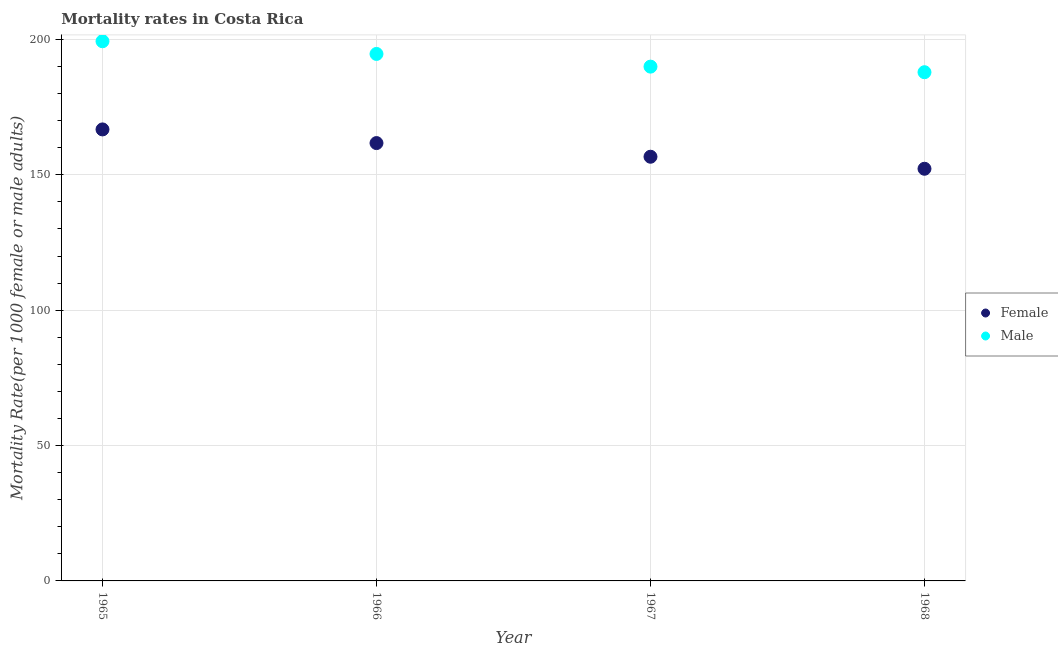How many different coloured dotlines are there?
Provide a short and direct response. 2. What is the male mortality rate in 1965?
Your answer should be compact. 199.33. Across all years, what is the maximum female mortality rate?
Provide a succinct answer. 166.76. Across all years, what is the minimum male mortality rate?
Keep it short and to the point. 187.89. In which year was the female mortality rate maximum?
Offer a very short reply. 1965. In which year was the male mortality rate minimum?
Provide a short and direct response. 1968. What is the total female mortality rate in the graph?
Ensure brevity in your answer.  637.38. What is the difference between the female mortality rate in 1965 and that in 1968?
Offer a terse response. 14.53. What is the difference between the male mortality rate in 1968 and the female mortality rate in 1967?
Your answer should be compact. 31.22. What is the average female mortality rate per year?
Ensure brevity in your answer.  159.34. In the year 1965, what is the difference between the male mortality rate and female mortality rate?
Ensure brevity in your answer.  32.56. What is the ratio of the female mortality rate in 1966 to that in 1967?
Your response must be concise. 1.03. Is the difference between the male mortality rate in 1965 and 1966 greater than the difference between the female mortality rate in 1965 and 1966?
Ensure brevity in your answer.  No. What is the difference between the highest and the second highest male mortality rate?
Offer a very short reply. 4.69. What is the difference between the highest and the lowest male mortality rate?
Offer a terse response. 11.43. Is the sum of the female mortality rate in 1965 and 1967 greater than the maximum male mortality rate across all years?
Your response must be concise. Yes. Is the male mortality rate strictly greater than the female mortality rate over the years?
Offer a very short reply. Yes. Is the male mortality rate strictly less than the female mortality rate over the years?
Provide a succinct answer. No. How many dotlines are there?
Offer a very short reply. 2. How many years are there in the graph?
Offer a very short reply. 4. What is the difference between two consecutive major ticks on the Y-axis?
Offer a terse response. 50. Are the values on the major ticks of Y-axis written in scientific E-notation?
Give a very brief answer. No. Does the graph contain any zero values?
Make the answer very short. No. What is the title of the graph?
Offer a terse response. Mortality rates in Costa Rica. What is the label or title of the Y-axis?
Offer a very short reply. Mortality Rate(per 1000 female or male adults). What is the Mortality Rate(per 1000 female or male adults) of Female in 1965?
Make the answer very short. 166.76. What is the Mortality Rate(per 1000 female or male adults) of Male in 1965?
Your response must be concise. 199.33. What is the Mortality Rate(per 1000 female or male adults) of Female in 1966?
Give a very brief answer. 161.72. What is the Mortality Rate(per 1000 female or male adults) in Male in 1966?
Offer a very short reply. 194.64. What is the Mortality Rate(per 1000 female or male adults) in Female in 1967?
Keep it short and to the point. 156.67. What is the Mortality Rate(per 1000 female or male adults) of Male in 1967?
Your answer should be compact. 189.95. What is the Mortality Rate(per 1000 female or male adults) in Female in 1968?
Provide a short and direct response. 152.23. What is the Mortality Rate(per 1000 female or male adults) of Male in 1968?
Give a very brief answer. 187.89. Across all years, what is the maximum Mortality Rate(per 1000 female or male adults) of Female?
Your response must be concise. 166.76. Across all years, what is the maximum Mortality Rate(per 1000 female or male adults) in Male?
Offer a very short reply. 199.33. Across all years, what is the minimum Mortality Rate(per 1000 female or male adults) in Female?
Your answer should be very brief. 152.23. Across all years, what is the minimum Mortality Rate(per 1000 female or male adults) of Male?
Your answer should be compact. 187.89. What is the total Mortality Rate(per 1000 female or male adults) in Female in the graph?
Your answer should be compact. 637.38. What is the total Mortality Rate(per 1000 female or male adults) of Male in the graph?
Keep it short and to the point. 771.81. What is the difference between the Mortality Rate(per 1000 female or male adults) of Female in 1965 and that in 1966?
Your response must be concise. 5.04. What is the difference between the Mortality Rate(per 1000 female or male adults) in Male in 1965 and that in 1966?
Provide a short and direct response. 4.69. What is the difference between the Mortality Rate(per 1000 female or male adults) of Female in 1965 and that in 1967?
Give a very brief answer. 10.09. What is the difference between the Mortality Rate(per 1000 female or male adults) of Male in 1965 and that in 1967?
Make the answer very short. 9.37. What is the difference between the Mortality Rate(per 1000 female or male adults) in Female in 1965 and that in 1968?
Ensure brevity in your answer.  14.53. What is the difference between the Mortality Rate(per 1000 female or male adults) in Male in 1965 and that in 1968?
Make the answer very short. 11.43. What is the difference between the Mortality Rate(per 1000 female or male adults) of Female in 1966 and that in 1967?
Ensure brevity in your answer.  5.04. What is the difference between the Mortality Rate(per 1000 female or male adults) of Male in 1966 and that in 1967?
Your answer should be very brief. 4.69. What is the difference between the Mortality Rate(per 1000 female or male adults) of Female in 1966 and that in 1968?
Provide a succinct answer. 9.49. What is the difference between the Mortality Rate(per 1000 female or male adults) in Male in 1966 and that in 1968?
Your answer should be compact. 6.75. What is the difference between the Mortality Rate(per 1000 female or male adults) in Female in 1967 and that in 1968?
Ensure brevity in your answer.  4.44. What is the difference between the Mortality Rate(per 1000 female or male adults) of Male in 1967 and that in 1968?
Your answer should be compact. 2.06. What is the difference between the Mortality Rate(per 1000 female or male adults) in Female in 1965 and the Mortality Rate(per 1000 female or male adults) in Male in 1966?
Give a very brief answer. -27.88. What is the difference between the Mortality Rate(per 1000 female or male adults) in Female in 1965 and the Mortality Rate(per 1000 female or male adults) in Male in 1967?
Your answer should be compact. -23.19. What is the difference between the Mortality Rate(per 1000 female or male adults) in Female in 1965 and the Mortality Rate(per 1000 female or male adults) in Male in 1968?
Provide a succinct answer. -21.13. What is the difference between the Mortality Rate(per 1000 female or male adults) of Female in 1966 and the Mortality Rate(per 1000 female or male adults) of Male in 1967?
Offer a very short reply. -28.24. What is the difference between the Mortality Rate(per 1000 female or male adults) in Female in 1966 and the Mortality Rate(per 1000 female or male adults) in Male in 1968?
Your response must be concise. -26.18. What is the difference between the Mortality Rate(per 1000 female or male adults) of Female in 1967 and the Mortality Rate(per 1000 female or male adults) of Male in 1968?
Ensure brevity in your answer.  -31.22. What is the average Mortality Rate(per 1000 female or male adults) in Female per year?
Keep it short and to the point. 159.34. What is the average Mortality Rate(per 1000 female or male adults) in Male per year?
Your response must be concise. 192.95. In the year 1965, what is the difference between the Mortality Rate(per 1000 female or male adults) of Female and Mortality Rate(per 1000 female or male adults) of Male?
Make the answer very short. -32.56. In the year 1966, what is the difference between the Mortality Rate(per 1000 female or male adults) in Female and Mortality Rate(per 1000 female or male adults) in Male?
Your answer should be compact. -32.92. In the year 1967, what is the difference between the Mortality Rate(per 1000 female or male adults) of Female and Mortality Rate(per 1000 female or male adults) of Male?
Your response must be concise. -33.28. In the year 1968, what is the difference between the Mortality Rate(per 1000 female or male adults) in Female and Mortality Rate(per 1000 female or male adults) in Male?
Give a very brief answer. -35.66. What is the ratio of the Mortality Rate(per 1000 female or male adults) in Female in 1965 to that in 1966?
Offer a terse response. 1.03. What is the ratio of the Mortality Rate(per 1000 female or male adults) of Male in 1965 to that in 1966?
Keep it short and to the point. 1.02. What is the ratio of the Mortality Rate(per 1000 female or male adults) in Female in 1965 to that in 1967?
Provide a succinct answer. 1.06. What is the ratio of the Mortality Rate(per 1000 female or male adults) in Male in 1965 to that in 1967?
Your answer should be very brief. 1.05. What is the ratio of the Mortality Rate(per 1000 female or male adults) of Female in 1965 to that in 1968?
Make the answer very short. 1.1. What is the ratio of the Mortality Rate(per 1000 female or male adults) in Male in 1965 to that in 1968?
Your answer should be very brief. 1.06. What is the ratio of the Mortality Rate(per 1000 female or male adults) of Female in 1966 to that in 1967?
Offer a terse response. 1.03. What is the ratio of the Mortality Rate(per 1000 female or male adults) in Male in 1966 to that in 1967?
Ensure brevity in your answer.  1.02. What is the ratio of the Mortality Rate(per 1000 female or male adults) of Female in 1966 to that in 1968?
Your answer should be compact. 1.06. What is the ratio of the Mortality Rate(per 1000 female or male adults) of Male in 1966 to that in 1968?
Provide a short and direct response. 1.04. What is the ratio of the Mortality Rate(per 1000 female or male adults) in Female in 1967 to that in 1968?
Make the answer very short. 1.03. What is the ratio of the Mortality Rate(per 1000 female or male adults) of Male in 1967 to that in 1968?
Your answer should be compact. 1.01. What is the difference between the highest and the second highest Mortality Rate(per 1000 female or male adults) of Female?
Offer a terse response. 5.04. What is the difference between the highest and the second highest Mortality Rate(per 1000 female or male adults) in Male?
Provide a short and direct response. 4.69. What is the difference between the highest and the lowest Mortality Rate(per 1000 female or male adults) of Female?
Offer a terse response. 14.53. What is the difference between the highest and the lowest Mortality Rate(per 1000 female or male adults) in Male?
Your answer should be compact. 11.43. 